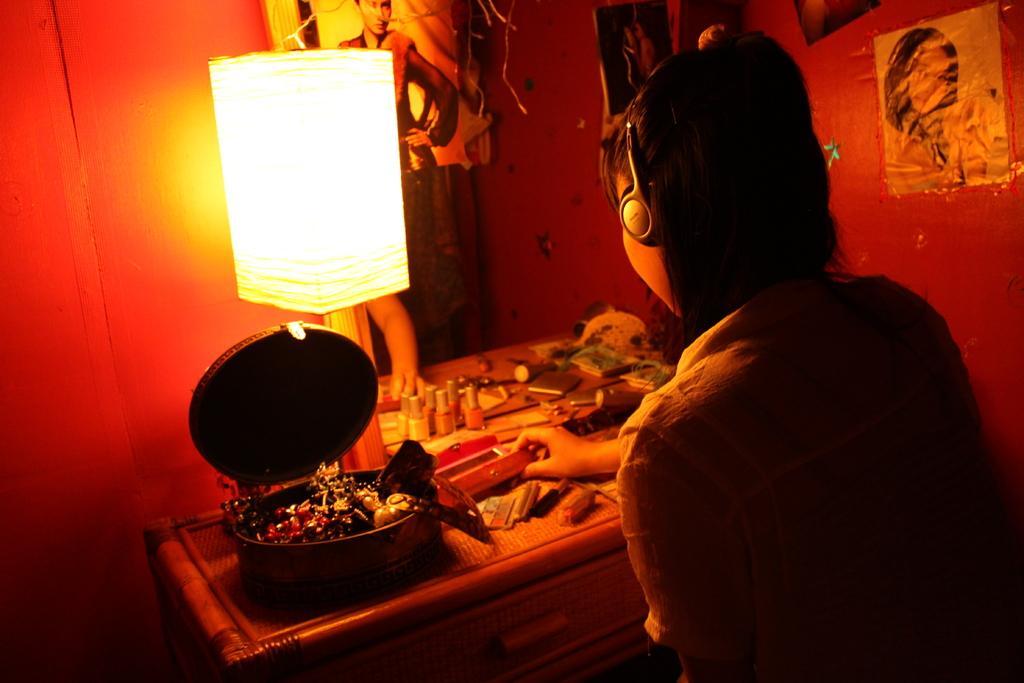In one or two sentences, can you explain what this image depicts? There is one woman wearing a headphone and holding an object on the right side of this image. There is a table with a mirror in the middle of this image, as we can see there are some objects kept on to this table. There is a light on the left side of this image. There is a wall in the background. There are some posters attached onto this wall. 